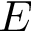<formula> <loc_0><loc_0><loc_500><loc_500>E</formula> 